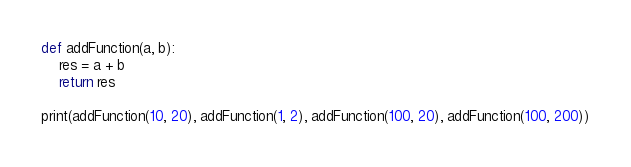<code> <loc_0><loc_0><loc_500><loc_500><_Python_>def addFunction(a, b):
    res = a + b
    return res

print(addFunction(10, 20), addFunction(1, 2), addFunction(100, 20), addFunction(100, 200))

</code> 